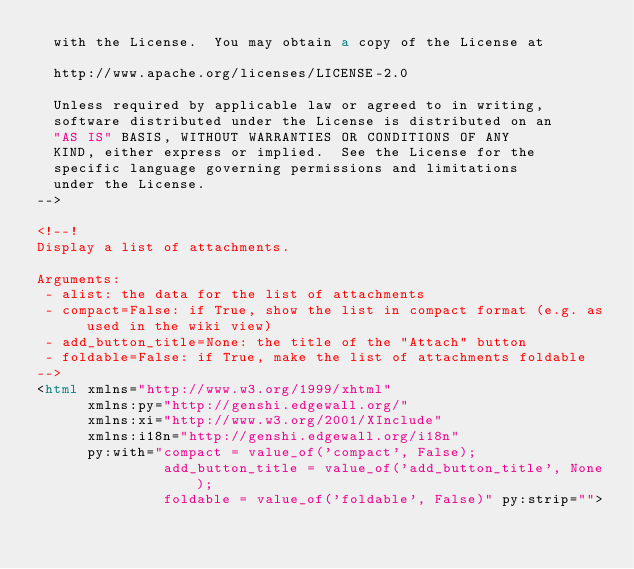Convert code to text. <code><loc_0><loc_0><loc_500><loc_500><_HTML_>  with the License.  You may obtain a copy of the License at

  http://www.apache.org/licenses/LICENSE-2.0

  Unless required by applicable law or agreed to in writing,
  software distributed under the License is distributed on an
  "AS IS" BASIS, WITHOUT WARRANTIES OR CONDITIONS OF ANY
  KIND, either express or implied.  See the License for the
  specific language governing permissions and limitations
  under the License.
-->

<!--!
Display a list of attachments.

Arguments:
 - alist: the data for the list of attachments
 - compact=False: if True, show the list in compact format (e.g. as used in the wiki view)
 - add_button_title=None: the title of the "Attach" button
 - foldable=False: if True, make the list of attachments foldable
-->
<html xmlns="http://www.w3.org/1999/xhtml"
      xmlns:py="http://genshi.edgewall.org/"
      xmlns:xi="http://www.w3.org/2001/XInclude"
      xmlns:i18n="http://genshi.edgewall.org/i18n"
      py:with="compact = value_of('compact', False);
               add_button_title = value_of('add_button_title', None);
               foldable = value_of('foldable', False)" py:strip=""></code> 